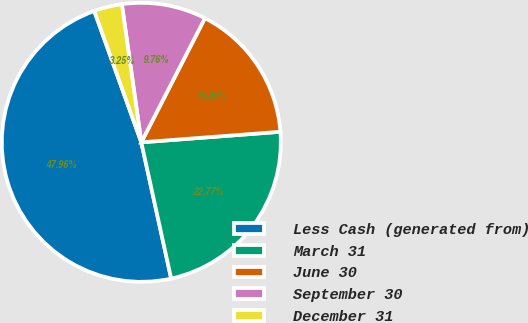Convert chart. <chart><loc_0><loc_0><loc_500><loc_500><pie_chart><fcel>Less Cash (generated from)<fcel>March 31<fcel>June 30<fcel>September 30<fcel>December 31<nl><fcel>47.96%<fcel>22.77%<fcel>16.26%<fcel>9.76%<fcel>3.25%<nl></chart> 